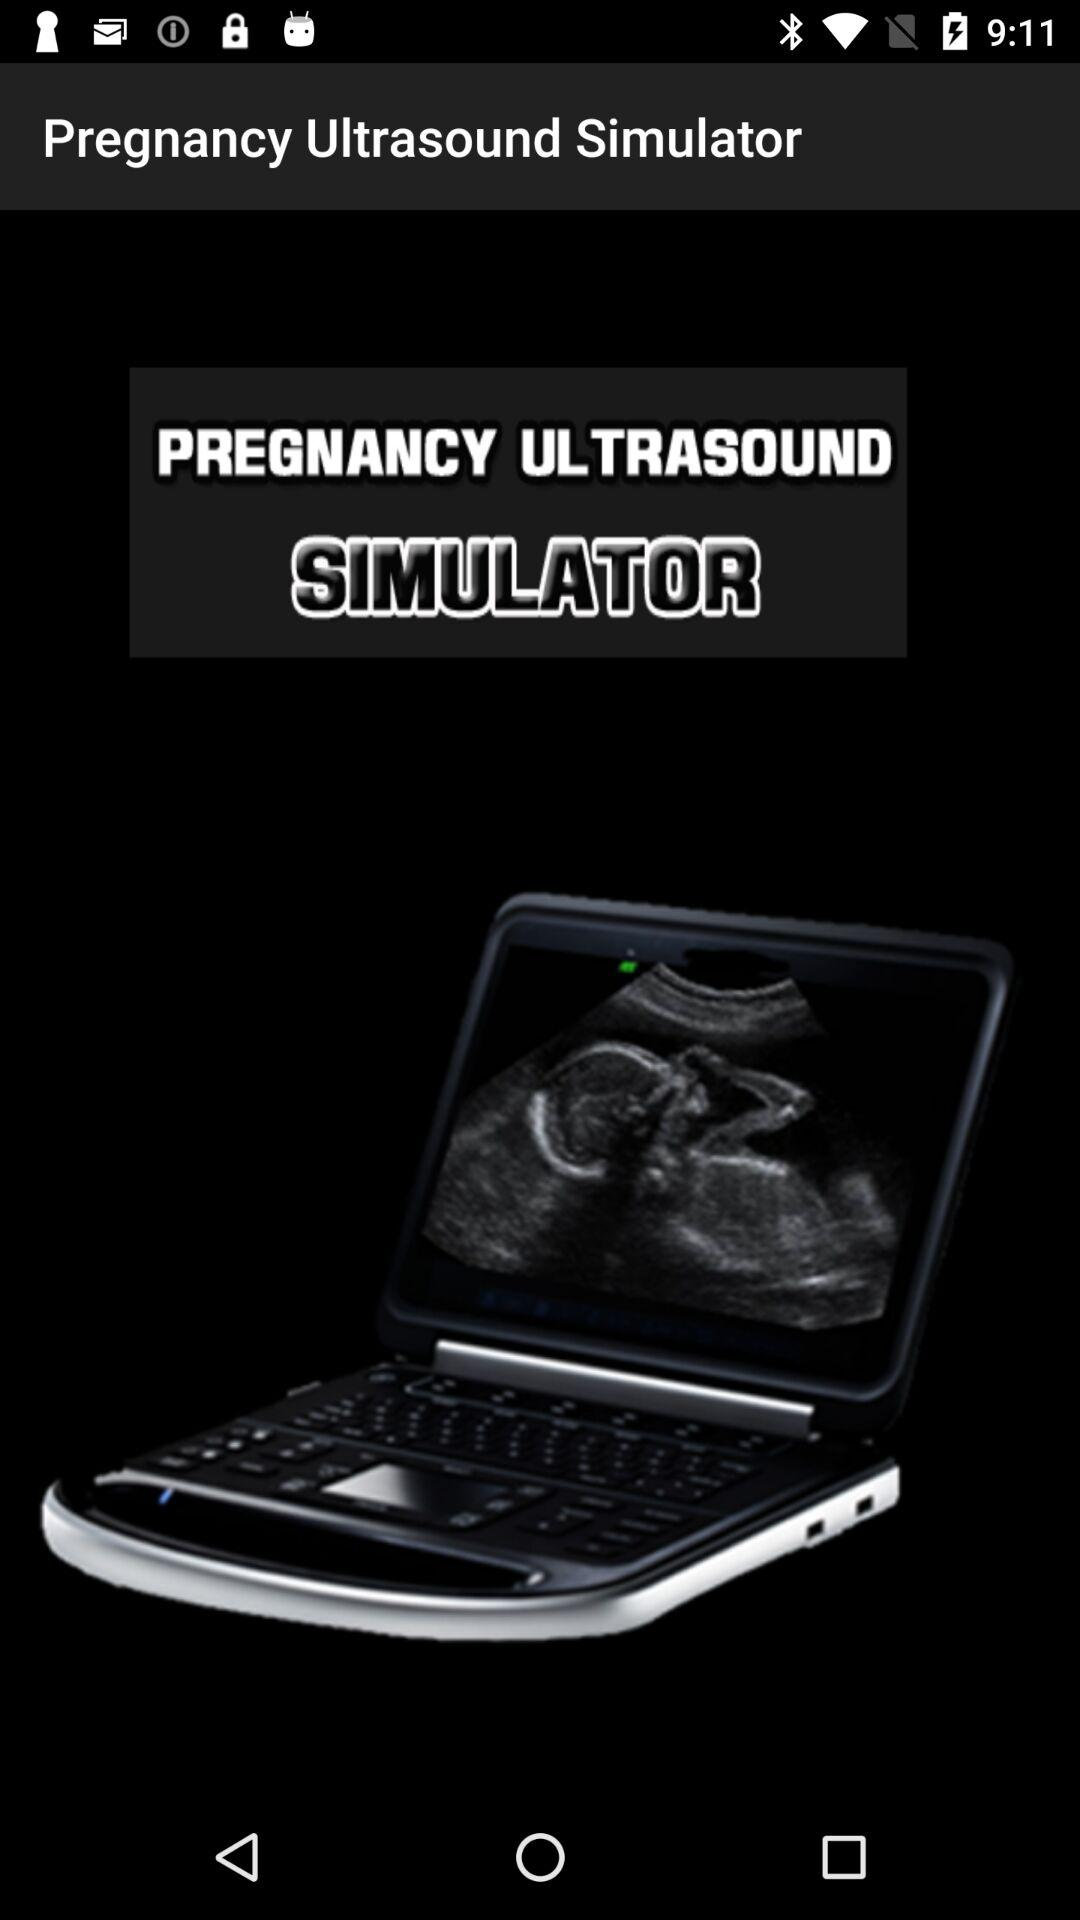What is the equipment name? The equipment name is the Pregnancy Ultrasound Simulator. 